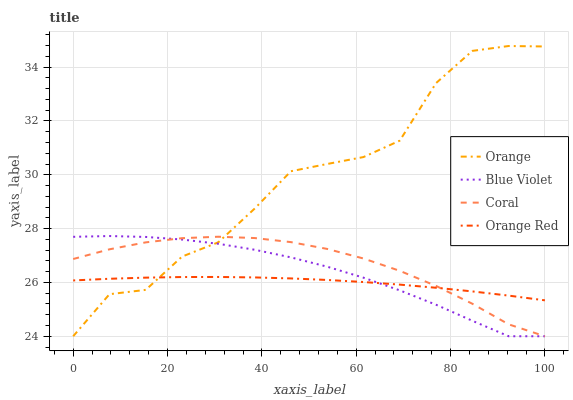Does Orange Red have the minimum area under the curve?
Answer yes or no. Yes. Does Orange have the maximum area under the curve?
Answer yes or no. Yes. Does Coral have the minimum area under the curve?
Answer yes or no. No. Does Coral have the maximum area under the curve?
Answer yes or no. No. Is Orange Red the smoothest?
Answer yes or no. Yes. Is Orange the roughest?
Answer yes or no. Yes. Is Coral the smoothest?
Answer yes or no. No. Is Coral the roughest?
Answer yes or no. No. Does Orange Red have the lowest value?
Answer yes or no. No. Does Orange have the highest value?
Answer yes or no. Yes. Does Coral have the highest value?
Answer yes or no. No. Does Orange intersect Blue Violet?
Answer yes or no. Yes. Is Orange less than Blue Violet?
Answer yes or no. No. Is Orange greater than Blue Violet?
Answer yes or no. No. 